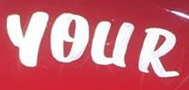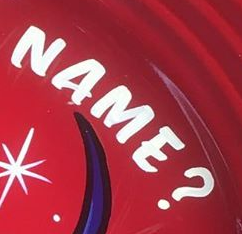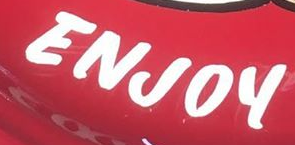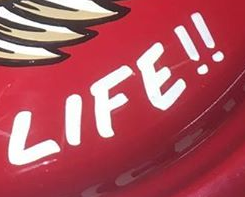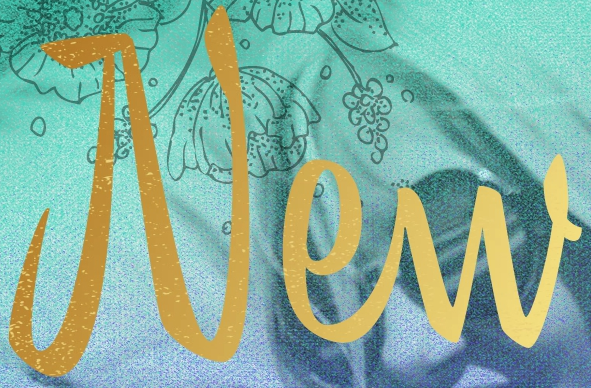What words are shown in these images in order, separated by a semicolon? YOUR; NAME?; ENJOY; LIFE!!; New 